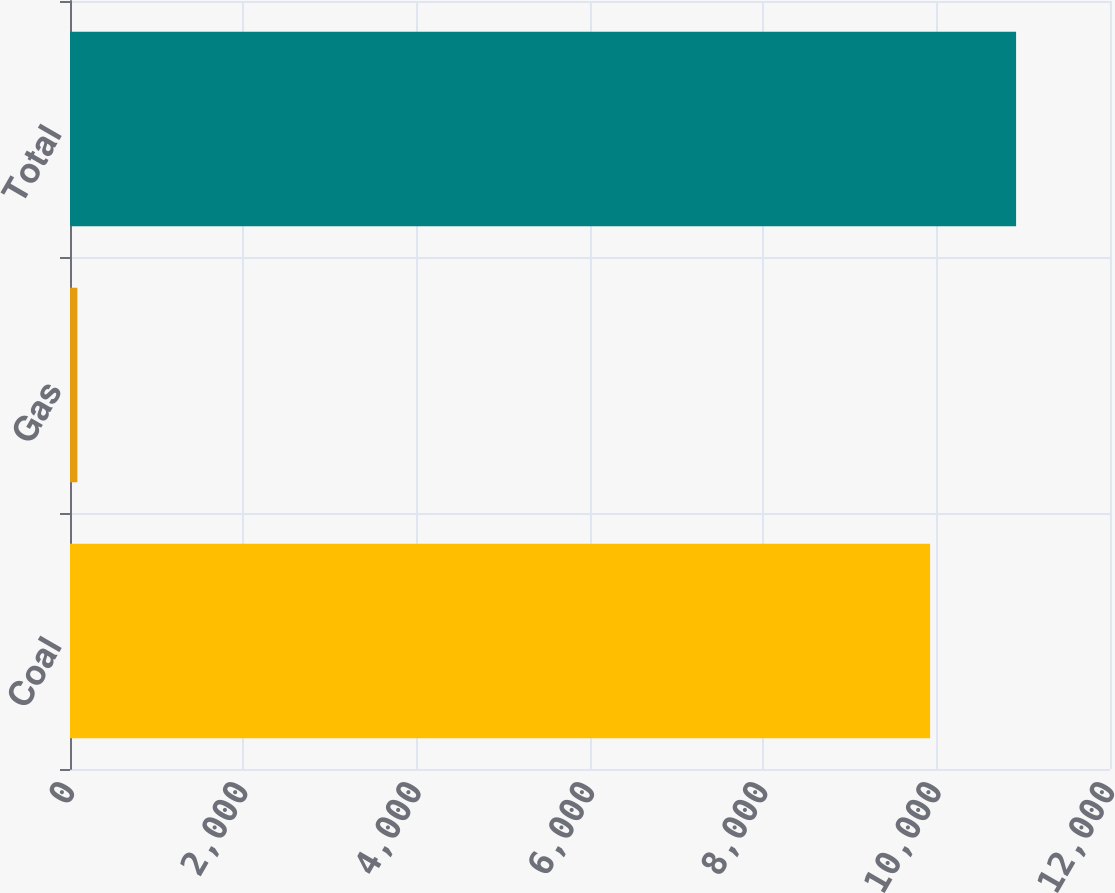<chart> <loc_0><loc_0><loc_500><loc_500><bar_chart><fcel>Coal<fcel>Gas<fcel>Total<nl><fcel>9924<fcel>85<fcel>10916.4<nl></chart> 